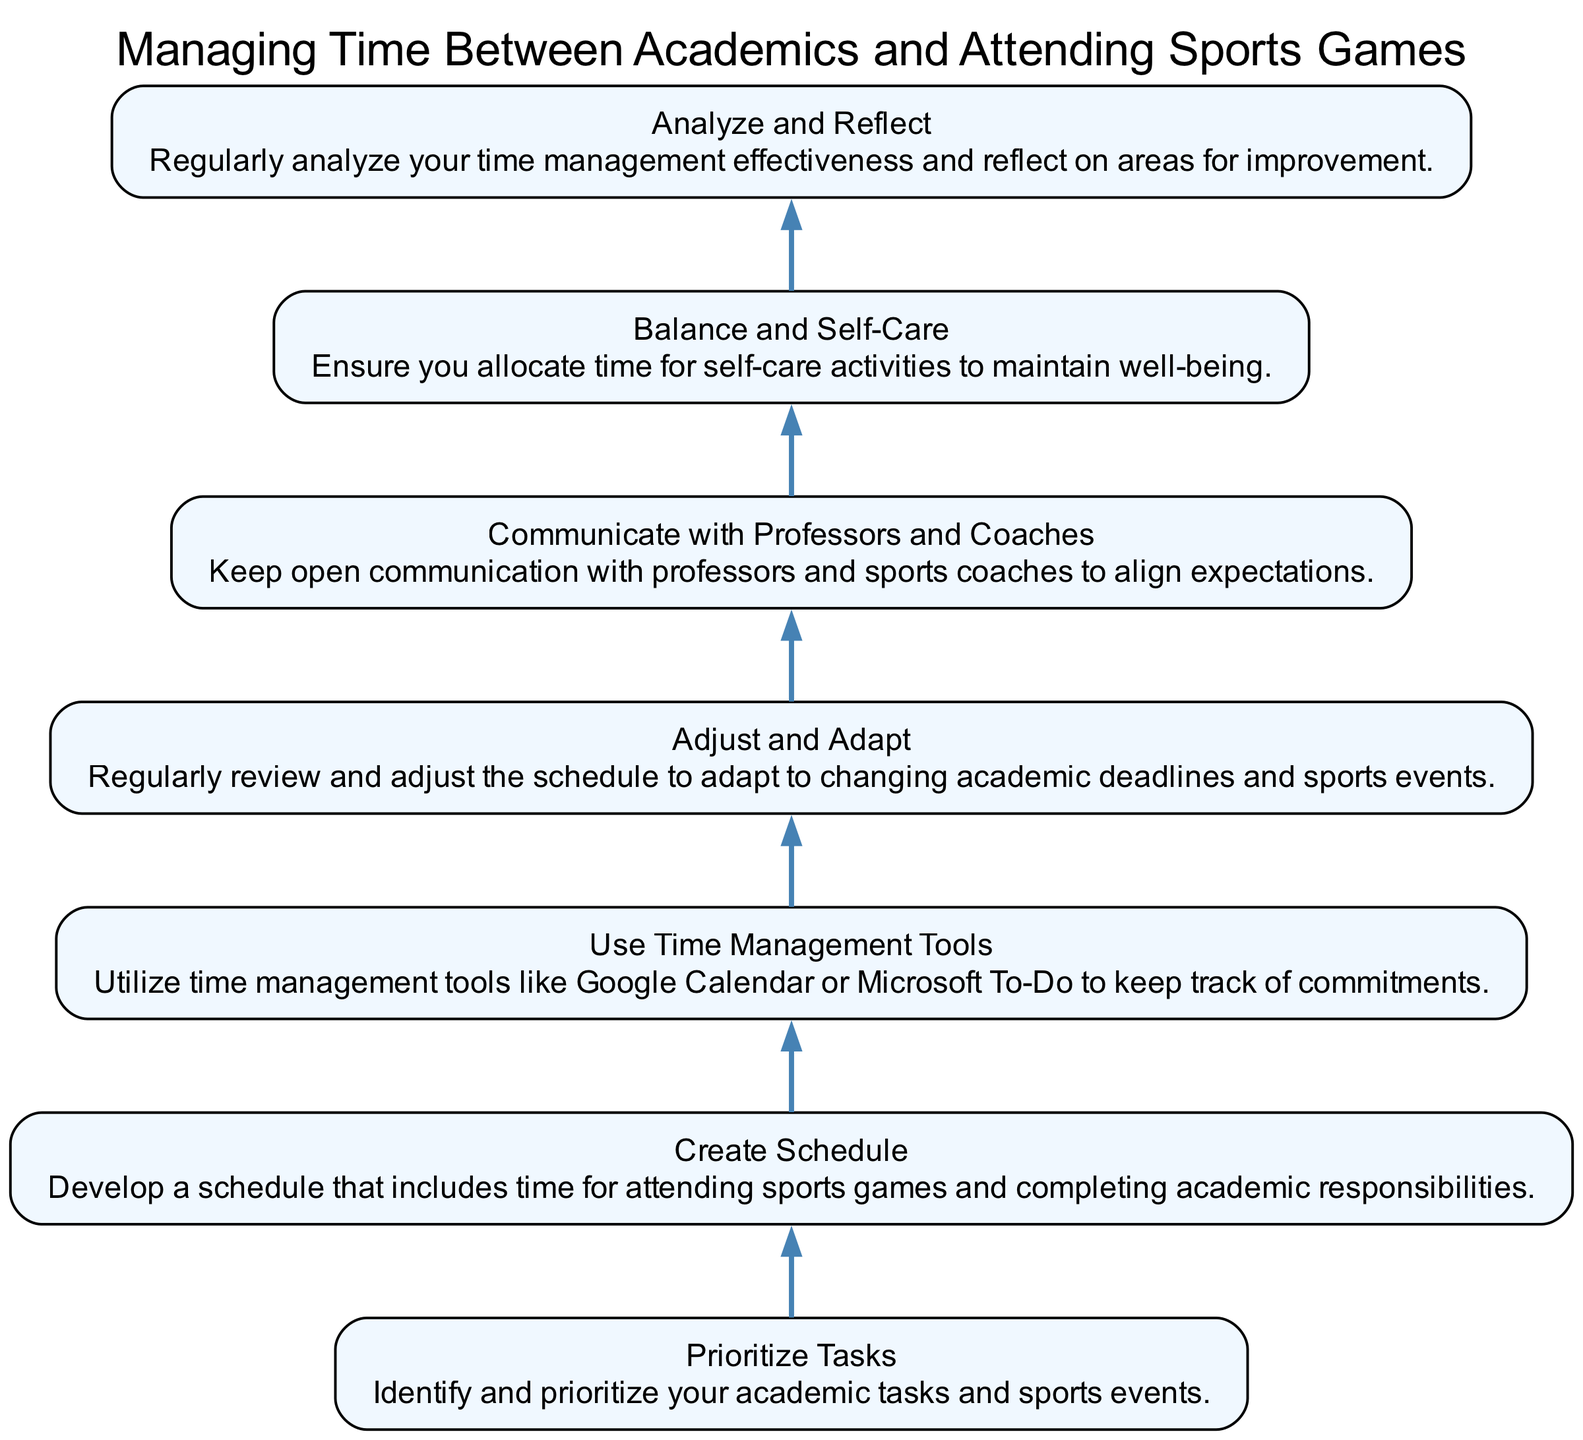What is the first step in managing time? The first step is "Prioritize Tasks," which is at the bottom of the diagram and has no dependencies. It sets the foundation for all subsequent steps.
Answer: Prioritize Tasks How many total nodes are in the diagram? The diagram contains seven distinct nodes that represent different steps until the final one at the top. Counting each unique step gives the total number of nodes as seven.
Answer: Seven What is the relationship between "Create Schedule" and "Prioritize Tasks"? "Create Schedule" depends on "Prioritize Tasks," meaning that a person must first complete the task of prioritizing before they can effectively create a schedule.
Answer: Create Schedule depends on Prioritize Tasks Which step involves using time management tools? The step involving using time management tools is "Use Time Management Tools," as indicated in the diagram after the creation of a schedule. It follows from the creation of the schedule.
Answer: Use Time Management Tools What must a student do before practicing "Balance and Self-Care"? A student must first "Communicate with Professors and Coaches" before they can practice "Balance and Self-Care." It shows the sequential importance of communication in the time management process.
Answer: Communicate with Professors and Coaches What happens after regularly analyzing time management effectiveness? After regularly analyzing time management effectiveness, the next step is to "Analyze and Reflect," which emphasizes the importance of reviewing one’s strategies for continuous improvement.
Answer: Analyze and Reflect Which step addresses health and wellness? The step that addresses health and wellness is "Balance and Self-Care," highlighting the need for personal well-being alongside academic and sports commitments.
Answer: Balance and Self-Care 